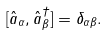Convert formula to latex. <formula><loc_0><loc_0><loc_500><loc_500>[ \hat { a } _ { \alpha } , \hat { a } ^ { \dagger } _ { \beta } ] = \delta _ { \alpha \beta } .</formula> 